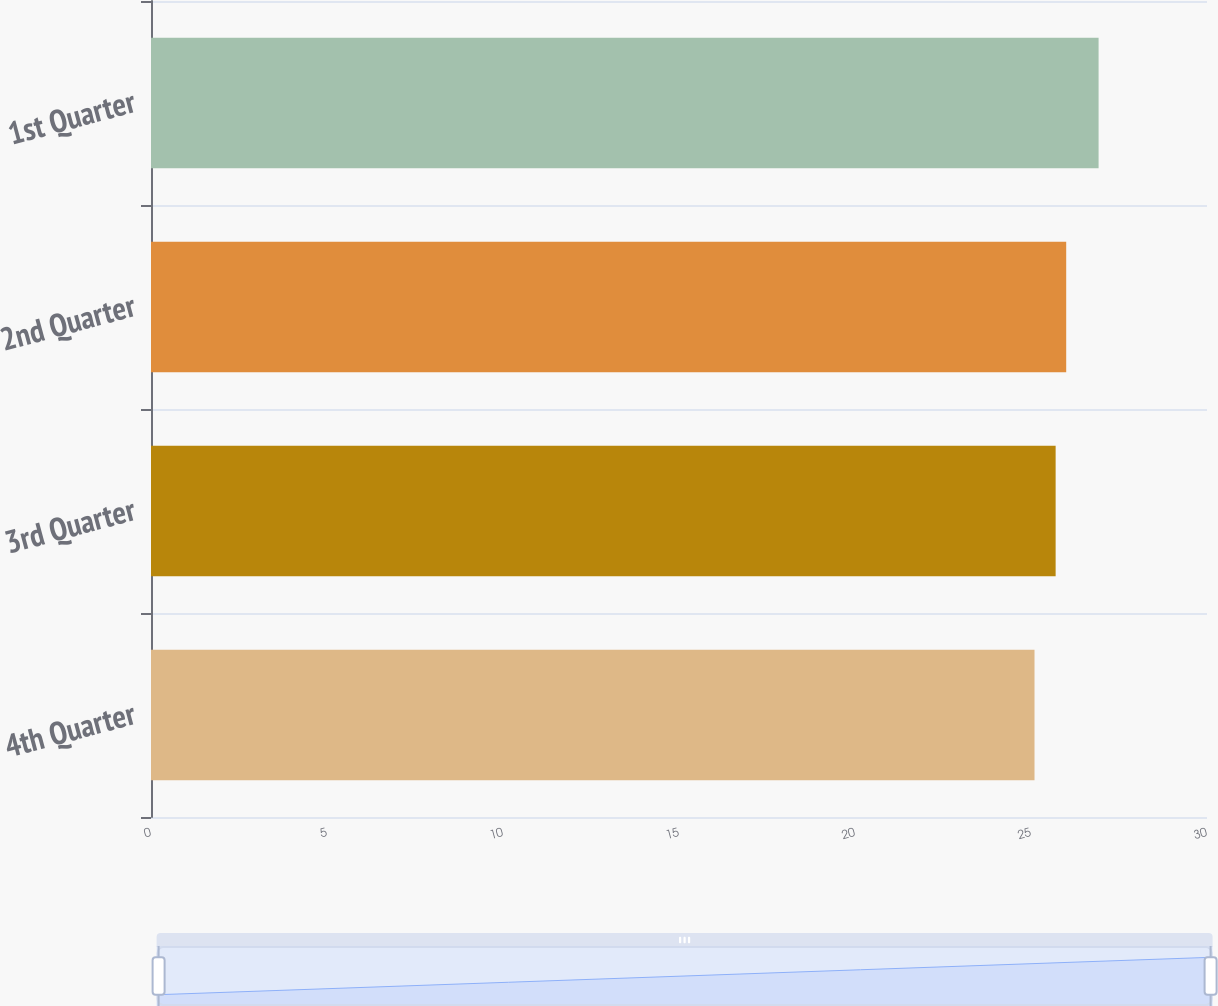Convert chart to OTSL. <chart><loc_0><loc_0><loc_500><loc_500><bar_chart><fcel>4th Quarter<fcel>3rd Quarter<fcel>2nd Quarter<fcel>1st Quarter<nl><fcel>25.1<fcel>25.7<fcel>26<fcel>26.92<nl></chart> 